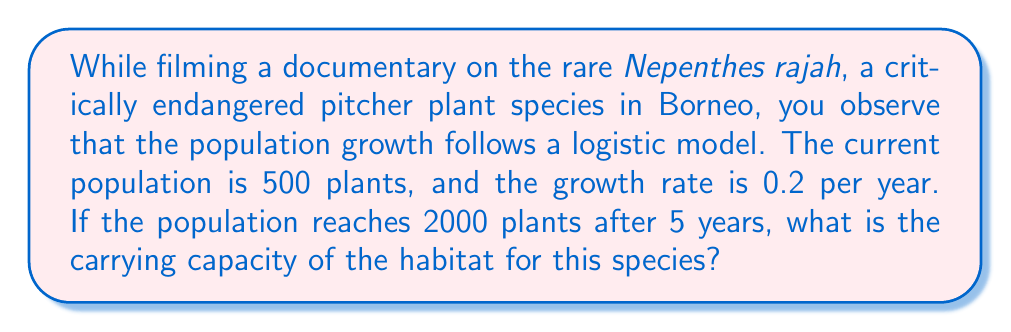Can you answer this question? To solve this problem, we'll use the logistic growth model:

$$N(t) = \frac{K}{1 + (\frac{K}{N_0} - 1)e^{-rt}}$$

Where:
$N(t)$ is the population at time $t$
$K$ is the carrying capacity
$N_0$ is the initial population
$r$ is the growth rate
$t$ is the time

Given:
$N_0 = 500$
$r = 0.2$
$t = 5$
$N(5) = 2000$

Step 1: Substitute the known values into the logistic growth equation:

$$2000 = \frac{K}{1 + (\frac{K}{500} - 1)e^{-0.2 \cdot 5}}$$

Step 2: Simplify the exponent:

$$2000 = \frac{K}{1 + (\frac{K}{500} - 1)e^{-1}}$$

Step 3: Multiply both sides by the denominator:

$$2000(1 + (\frac{K}{500} - 1)e^{-1}) = K$$

Step 4: Expand the brackets:

$$2000 + 2000(\frac{K}{500} - 1)e^{-1} = K$$

Step 5: Simplify:

$$2000 + 4Ke^{-1} - 2000e^{-1} = K$$

Step 6: Rearrange to standard form:

$$4Ke^{-1} - K + 2000 - 2000e^{-1} = 0$$

Step 7: Factor out K:

$$K(4e^{-1} - 1) = 2000e^{-1} - 2000$$

Step 8: Solve for K:

$$K = \frac{2000e^{-1} - 2000}{4e^{-1} - 1}$$

Step 9: Calculate the value (rounded to the nearest whole number):

$$K \approx 2466$$
Answer: 2466 plants 